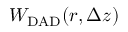<formula> <loc_0><loc_0><loc_500><loc_500>W _ { D A D } ( r , \Delta z )</formula> 